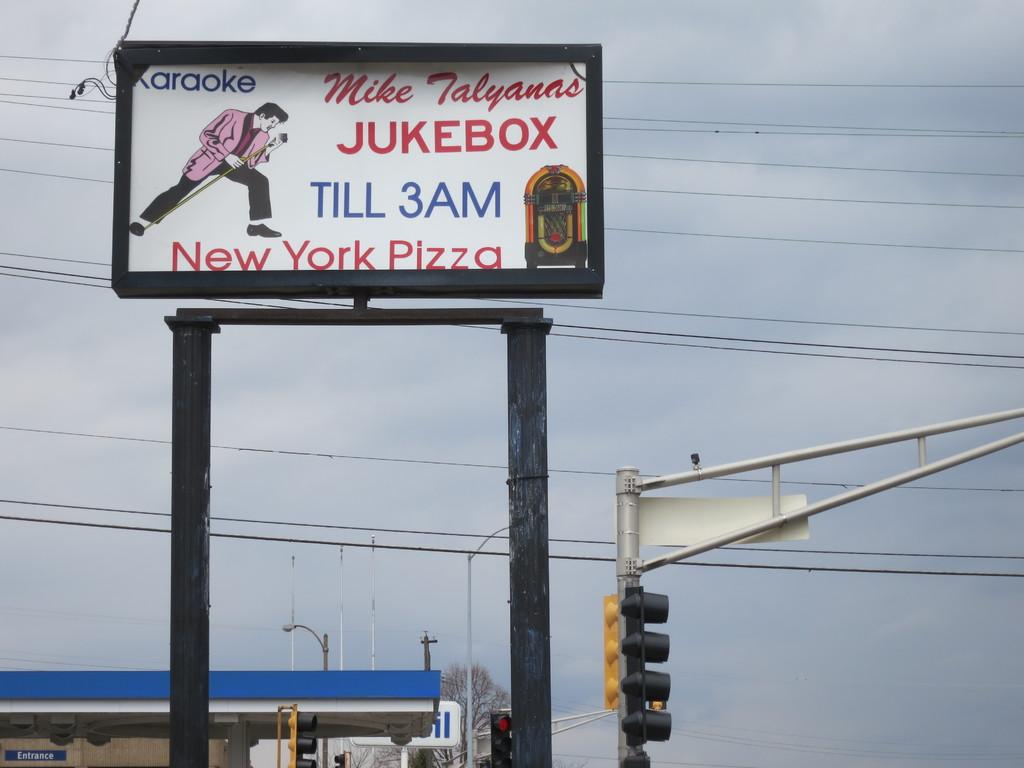<image>
Write a terse but informative summary of the picture. A restaurant called the Jukebox, is open to 3 AM and sells Pizza. 